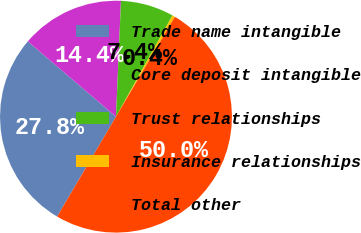Convert chart. <chart><loc_0><loc_0><loc_500><loc_500><pie_chart><fcel>Trade name intangible<fcel>Core deposit intangible<fcel>Trust relationships<fcel>Insurance relationships<fcel>Total other<nl><fcel>27.78%<fcel>14.44%<fcel>7.41%<fcel>0.38%<fcel>50.0%<nl></chart> 